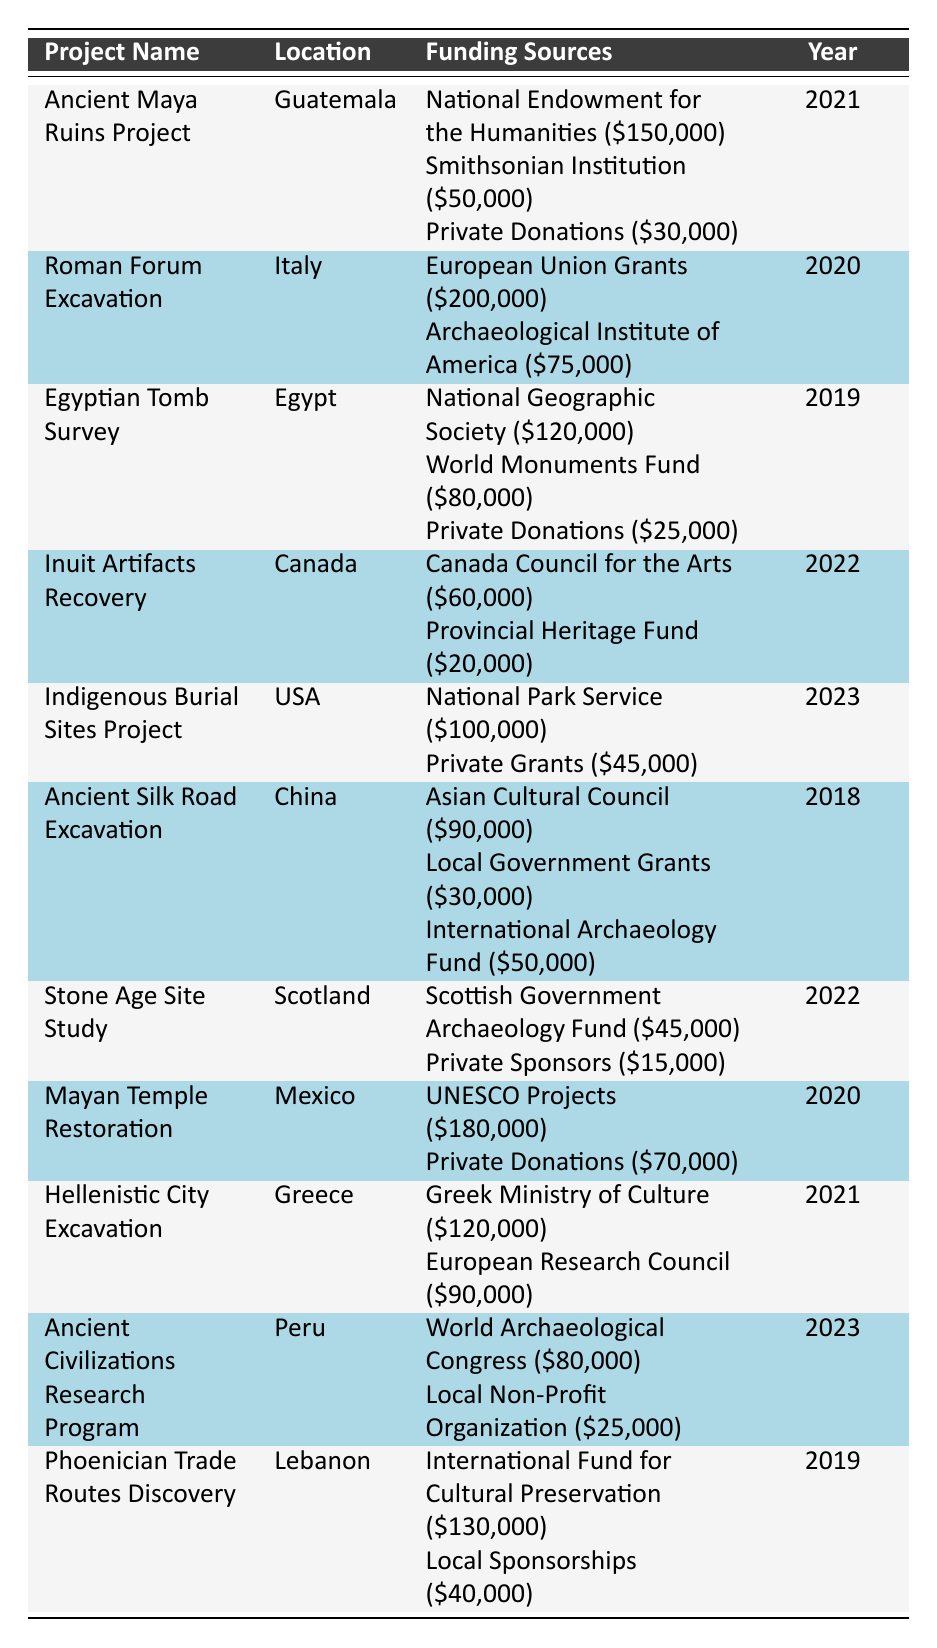What was the funding amount for the Roman Forum Excavation? The Roman Forum Excavation received funding from two sources: European Union Grants totaling $200,000 and the Archaeological Institute of America amounting to $75,000. The total funding is $200,000 + $75,000 = $275,000.
Answer: $275,000 Which project received the highest total funding? Among the projects listed, the Roman Forum Excavation received the highest total funding of $275,000 from its funding sources.
Answer: Roman Forum Excavation How much funding did the Ancient Maya Ruins Project receive from Private Donations? The Ancient Maya Ruins Project received $30,000 specifically from Private Donations, as stated in the funding sources section.
Answer: $30,000 Was the Hellenistic City Excavation funded in 2020? The Hellenistic City Excavation was funded in the year 2021, not in 2020 as per the year listed in the table.
Answer: No What is the total funding amount for projects based in the USA? For the USA, there are two projects: Indigenous Burial Sites Project with a total of $145,000 ($100,000 from National Park Service and $45,000 from Private Grants) and another with $105,000 ($80,000 for Ancient Civilizations Research Program and $25,000 from Local Non-Profit Organization). The total from both is $145,000 + $105,000 = $250,000.
Answer: $250,000 What is the median funding amount of all the excavation projects? To find the median, we first list the total funding amounts of all projects: $275,000, $250,000, $225,000, $120,000, $100,000, $180,000, $120,000, $80,000, $130,000. Sorting these gives us: $80,000, $100,000, $120,000, $120,000, $130,000, $180,000, $225,000, $250,000, $275,000. The median is the middle value which is $120,000 (the 5th and 6th values are identical, so both are used).
Answer: $120,000 How many projects received funding from UNESCO initiatives? Only one project, the Mayan Temple Restoration, lists funding from UNESCO Projects for a total of $180,000.
Answer: 1 Which location has the least amount of funding received among the listed projects? The Stone Age Site Study in Scotland received a total of $60,000, which is less than any other project amount listed in the table, making it the least funded project.
Answer: Scotland Did the Ancient Silk Road Excavation receive funding from Local Government Grants? Yes, the Ancient Silk Road Excavation received $30,000 from Local Government Grants as one of its funding sources.
Answer: Yes What total funding did the Inuit Artifacts Recovery project receive? The Inuit Artifacts Recovery project received funding from two sources: Canada Council for the Arts ($60,000) and Provincial Heritage Fund ($20,000). Adding these amounts gives $60,000 + $20,000 = $80,000 total funding.
Answer: $80,000 How much more funding did the Egyptian Tomb Survey receive compared to the Ancient Silk Road Excavation? The Egyptian Tomb Survey received a total of $225,000 while the Ancient Silk Road Excavation received a total of $170,000. The difference is calculated as $225,000 - $170,000 = $55,000.
Answer: $55,000 